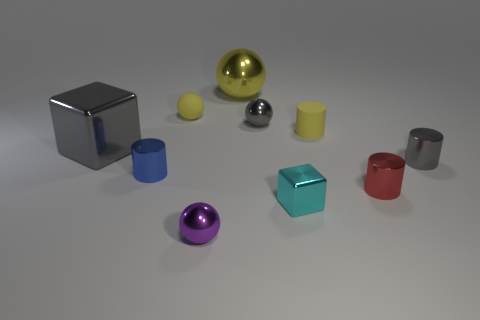There is a tiny object that is made of the same material as the tiny yellow cylinder; what is its color?
Your answer should be compact. Yellow. How many small things are the same material as the gray sphere?
Keep it short and to the point. 5. How many things are blue matte balls or tiny gray metallic things on the right side of the red cylinder?
Your answer should be very brief. 1. Do the yellow object behind the small yellow ball and the blue object have the same material?
Offer a terse response. Yes. There is a rubber cylinder that is the same size as the gray ball; what is its color?
Make the answer very short. Yellow. Is there a big thing of the same shape as the tiny red object?
Make the answer very short. No. What is the color of the small shiny ball that is behind the small shiny ball on the left side of the tiny shiny ball behind the blue cylinder?
Your answer should be very brief. Gray. What number of shiny objects are large cubes or blue things?
Provide a short and direct response. 2. Is the number of tiny metal balls behind the big cube greater than the number of purple metal spheres that are behind the blue object?
Your answer should be compact. Yes. How many other things are the same size as the yellow rubber sphere?
Offer a very short reply. 7. 